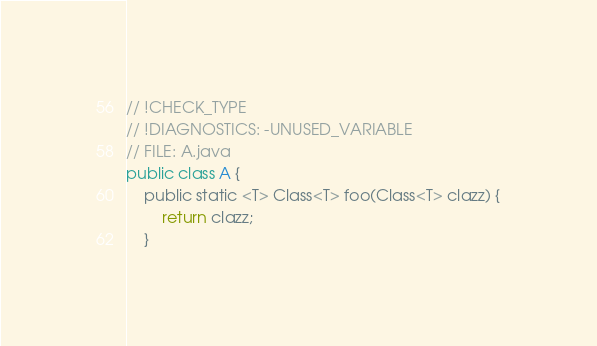<code> <loc_0><loc_0><loc_500><loc_500><_Kotlin_>// !CHECK_TYPE
// !DIAGNOSTICS: -UNUSED_VARIABLE
// FILE: A.java
public class A {
    public static <T> Class<T> foo(Class<T> clazz) {
        return clazz;
    }
</code> 